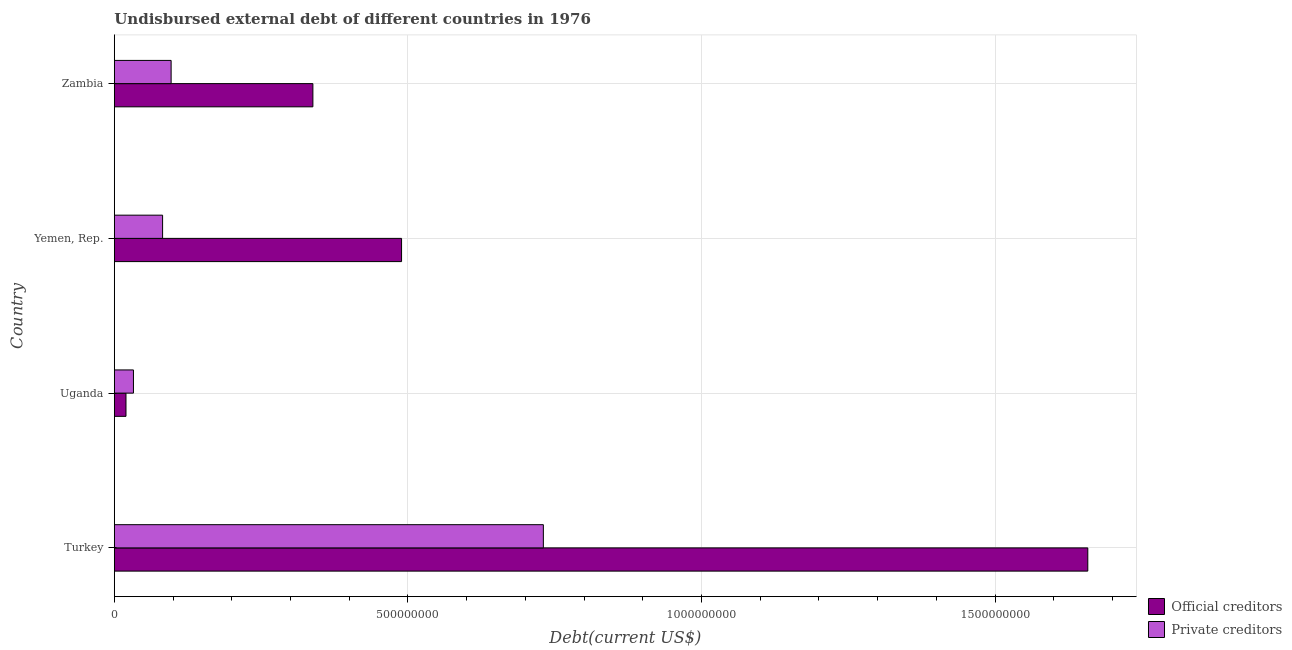Are the number of bars per tick equal to the number of legend labels?
Provide a succinct answer. Yes. How many bars are there on the 4th tick from the top?
Offer a terse response. 2. What is the label of the 1st group of bars from the top?
Keep it short and to the point. Zambia. In how many cases, is the number of bars for a given country not equal to the number of legend labels?
Provide a succinct answer. 0. What is the undisbursed external debt of private creditors in Yemen, Rep.?
Ensure brevity in your answer.  8.22e+07. Across all countries, what is the maximum undisbursed external debt of private creditors?
Offer a very short reply. 7.31e+08. Across all countries, what is the minimum undisbursed external debt of private creditors?
Your answer should be very brief. 3.26e+07. In which country was the undisbursed external debt of private creditors maximum?
Offer a terse response. Turkey. In which country was the undisbursed external debt of private creditors minimum?
Ensure brevity in your answer.  Uganda. What is the total undisbursed external debt of official creditors in the graph?
Offer a terse response. 2.51e+09. What is the difference between the undisbursed external debt of private creditors in Uganda and that in Zambia?
Ensure brevity in your answer.  -6.42e+07. What is the difference between the undisbursed external debt of official creditors in Turkey and the undisbursed external debt of private creditors in Uganda?
Your response must be concise. 1.63e+09. What is the average undisbursed external debt of official creditors per country?
Your answer should be very brief. 6.26e+08. What is the difference between the undisbursed external debt of official creditors and undisbursed external debt of private creditors in Yemen, Rep.?
Give a very brief answer. 4.07e+08. What is the ratio of the undisbursed external debt of official creditors in Turkey to that in Uganda?
Provide a succinct answer. 83.39. Is the undisbursed external debt of private creditors in Uganda less than that in Yemen, Rep.?
Your answer should be very brief. Yes. What is the difference between the highest and the second highest undisbursed external debt of official creditors?
Offer a terse response. 1.17e+09. What is the difference between the highest and the lowest undisbursed external debt of private creditors?
Make the answer very short. 6.98e+08. Is the sum of the undisbursed external debt of private creditors in Turkey and Zambia greater than the maximum undisbursed external debt of official creditors across all countries?
Your answer should be compact. No. What does the 1st bar from the top in Turkey represents?
Offer a terse response. Private creditors. What does the 1st bar from the bottom in Zambia represents?
Your answer should be very brief. Official creditors. Are the values on the major ticks of X-axis written in scientific E-notation?
Provide a short and direct response. No. Does the graph contain grids?
Ensure brevity in your answer.  Yes. How many legend labels are there?
Your response must be concise. 2. What is the title of the graph?
Ensure brevity in your answer.  Undisbursed external debt of different countries in 1976. What is the label or title of the X-axis?
Your response must be concise. Debt(current US$). What is the Debt(current US$) in Official creditors in Turkey?
Provide a succinct answer. 1.66e+09. What is the Debt(current US$) of Private creditors in Turkey?
Offer a terse response. 7.31e+08. What is the Debt(current US$) of Official creditors in Uganda?
Offer a very short reply. 1.99e+07. What is the Debt(current US$) in Private creditors in Uganda?
Keep it short and to the point. 3.26e+07. What is the Debt(current US$) in Official creditors in Yemen, Rep.?
Offer a very short reply. 4.89e+08. What is the Debt(current US$) of Private creditors in Yemen, Rep.?
Offer a very short reply. 8.22e+07. What is the Debt(current US$) in Official creditors in Zambia?
Your response must be concise. 3.38e+08. What is the Debt(current US$) in Private creditors in Zambia?
Give a very brief answer. 9.68e+07. Across all countries, what is the maximum Debt(current US$) in Official creditors?
Give a very brief answer. 1.66e+09. Across all countries, what is the maximum Debt(current US$) of Private creditors?
Keep it short and to the point. 7.31e+08. Across all countries, what is the minimum Debt(current US$) in Official creditors?
Give a very brief answer. 1.99e+07. Across all countries, what is the minimum Debt(current US$) in Private creditors?
Your answer should be very brief. 3.26e+07. What is the total Debt(current US$) in Official creditors in the graph?
Offer a terse response. 2.51e+09. What is the total Debt(current US$) of Private creditors in the graph?
Your answer should be very brief. 9.42e+08. What is the difference between the Debt(current US$) of Official creditors in Turkey and that in Uganda?
Ensure brevity in your answer.  1.64e+09. What is the difference between the Debt(current US$) of Private creditors in Turkey and that in Uganda?
Provide a succinct answer. 6.98e+08. What is the difference between the Debt(current US$) of Official creditors in Turkey and that in Yemen, Rep.?
Provide a short and direct response. 1.17e+09. What is the difference between the Debt(current US$) of Private creditors in Turkey and that in Yemen, Rep.?
Your answer should be very brief. 6.48e+08. What is the difference between the Debt(current US$) in Official creditors in Turkey and that in Zambia?
Make the answer very short. 1.32e+09. What is the difference between the Debt(current US$) of Private creditors in Turkey and that in Zambia?
Your response must be concise. 6.34e+08. What is the difference between the Debt(current US$) of Official creditors in Uganda and that in Yemen, Rep.?
Offer a terse response. -4.69e+08. What is the difference between the Debt(current US$) in Private creditors in Uganda and that in Yemen, Rep.?
Offer a very short reply. -4.96e+07. What is the difference between the Debt(current US$) in Official creditors in Uganda and that in Zambia?
Offer a very short reply. -3.18e+08. What is the difference between the Debt(current US$) in Private creditors in Uganda and that in Zambia?
Your response must be concise. -6.42e+07. What is the difference between the Debt(current US$) of Official creditors in Yemen, Rep. and that in Zambia?
Your answer should be very brief. 1.51e+08. What is the difference between the Debt(current US$) in Private creditors in Yemen, Rep. and that in Zambia?
Provide a succinct answer. -1.45e+07. What is the difference between the Debt(current US$) in Official creditors in Turkey and the Debt(current US$) in Private creditors in Uganda?
Offer a very short reply. 1.63e+09. What is the difference between the Debt(current US$) in Official creditors in Turkey and the Debt(current US$) in Private creditors in Yemen, Rep.?
Offer a very short reply. 1.58e+09. What is the difference between the Debt(current US$) in Official creditors in Turkey and the Debt(current US$) in Private creditors in Zambia?
Your response must be concise. 1.56e+09. What is the difference between the Debt(current US$) in Official creditors in Uganda and the Debt(current US$) in Private creditors in Yemen, Rep.?
Provide a succinct answer. -6.23e+07. What is the difference between the Debt(current US$) of Official creditors in Uganda and the Debt(current US$) of Private creditors in Zambia?
Your response must be concise. -7.69e+07. What is the difference between the Debt(current US$) in Official creditors in Yemen, Rep. and the Debt(current US$) in Private creditors in Zambia?
Keep it short and to the point. 3.92e+08. What is the average Debt(current US$) in Official creditors per country?
Your response must be concise. 6.26e+08. What is the average Debt(current US$) in Private creditors per country?
Make the answer very short. 2.36e+08. What is the difference between the Debt(current US$) in Official creditors and Debt(current US$) in Private creditors in Turkey?
Give a very brief answer. 9.27e+08. What is the difference between the Debt(current US$) in Official creditors and Debt(current US$) in Private creditors in Uganda?
Your response must be concise. -1.27e+07. What is the difference between the Debt(current US$) of Official creditors and Debt(current US$) of Private creditors in Yemen, Rep.?
Provide a succinct answer. 4.07e+08. What is the difference between the Debt(current US$) of Official creditors and Debt(current US$) of Private creditors in Zambia?
Provide a succinct answer. 2.41e+08. What is the ratio of the Debt(current US$) of Official creditors in Turkey to that in Uganda?
Keep it short and to the point. 83.39. What is the ratio of the Debt(current US$) in Private creditors in Turkey to that in Uganda?
Provide a short and direct response. 22.42. What is the ratio of the Debt(current US$) of Official creditors in Turkey to that in Yemen, Rep.?
Your response must be concise. 3.39. What is the ratio of the Debt(current US$) of Private creditors in Turkey to that in Yemen, Rep.?
Keep it short and to the point. 8.89. What is the ratio of the Debt(current US$) of Official creditors in Turkey to that in Zambia?
Make the answer very short. 4.9. What is the ratio of the Debt(current US$) in Private creditors in Turkey to that in Zambia?
Your answer should be compact. 7.55. What is the ratio of the Debt(current US$) in Official creditors in Uganda to that in Yemen, Rep.?
Give a very brief answer. 0.04. What is the ratio of the Debt(current US$) of Private creditors in Uganda to that in Yemen, Rep.?
Ensure brevity in your answer.  0.4. What is the ratio of the Debt(current US$) in Official creditors in Uganda to that in Zambia?
Give a very brief answer. 0.06. What is the ratio of the Debt(current US$) of Private creditors in Uganda to that in Zambia?
Provide a succinct answer. 0.34. What is the ratio of the Debt(current US$) of Official creditors in Yemen, Rep. to that in Zambia?
Ensure brevity in your answer.  1.45. What is the ratio of the Debt(current US$) in Private creditors in Yemen, Rep. to that in Zambia?
Your answer should be very brief. 0.85. What is the difference between the highest and the second highest Debt(current US$) of Official creditors?
Your response must be concise. 1.17e+09. What is the difference between the highest and the second highest Debt(current US$) of Private creditors?
Provide a succinct answer. 6.34e+08. What is the difference between the highest and the lowest Debt(current US$) in Official creditors?
Provide a short and direct response. 1.64e+09. What is the difference between the highest and the lowest Debt(current US$) of Private creditors?
Provide a short and direct response. 6.98e+08. 